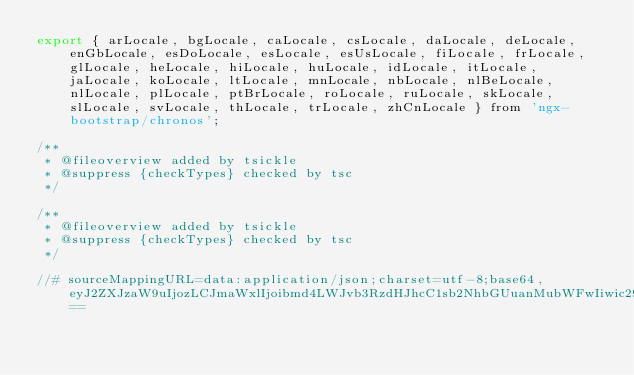Convert code to text. <code><loc_0><loc_0><loc_500><loc_500><_JavaScript_>export { arLocale, bgLocale, caLocale, csLocale, daLocale, deLocale, enGbLocale, esDoLocale, esLocale, esUsLocale, fiLocale, frLocale, glLocale, heLocale, hiLocale, huLocale, idLocale, itLocale, jaLocale, koLocale, ltLocale, mnLocale, nbLocale, nlBeLocale, nlLocale, plLocale, ptBrLocale, roLocale, ruLocale, skLocale, slLocale, svLocale, thLocale, trLocale, zhCnLocale } from 'ngx-bootstrap/chronos';

/**
 * @fileoverview added by tsickle
 * @suppress {checkTypes} checked by tsc
 */

/**
 * @fileoverview added by tsickle
 * @suppress {checkTypes} checked by tsc
 */

//# sourceMappingURL=data:application/json;charset=utf-8;base64,eyJ2ZXJzaW9uIjozLCJmaWxlIjoibmd4LWJvb3RzdHJhcC1sb2NhbGUuanMubWFwIiwic291cmNlcyI6W10sInNvdXJjZXNDb250ZW50IjpbXSwibmFtZXMiOltdLCJtYXBwaW5ncyI6Ijs7Ozs7Ozs7OzsifQ==</code> 